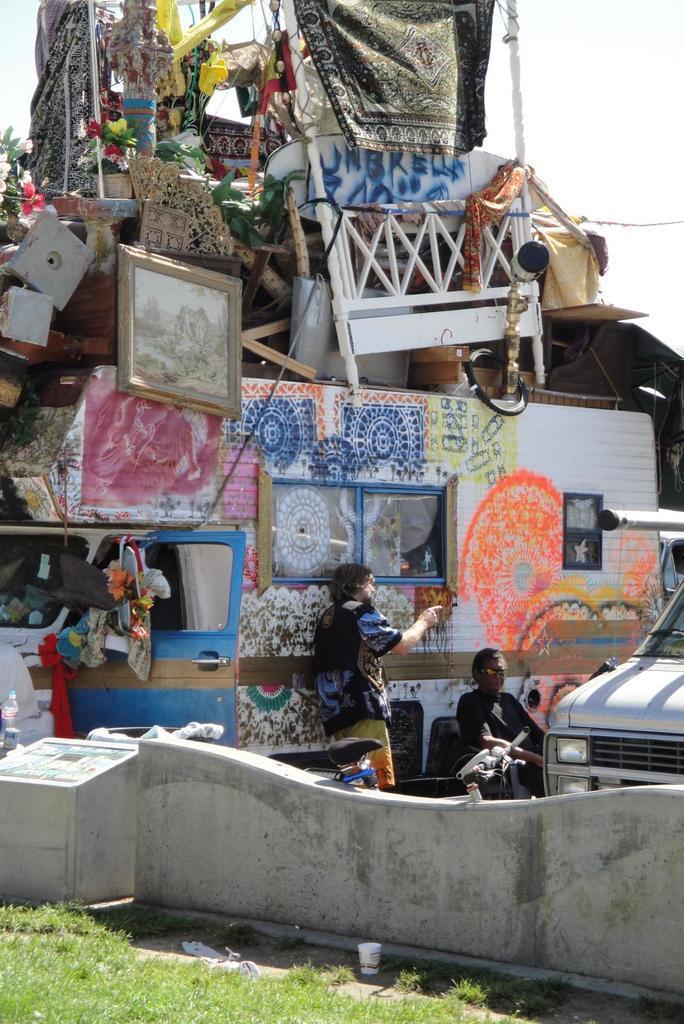Please provide a concise description of this image. This picture is clicked outside. In the foreground we can see the green grass and some objects placed on the ground. On the right corner we can see a vehicle and a person sitting and another person standing. On the left we can see a vehicle containing metal rods, picture frame, flowers and many other objects. In the background we can see the sky. 